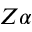Convert formula to latex. <formula><loc_0><loc_0><loc_500><loc_500>Z \alpha</formula> 